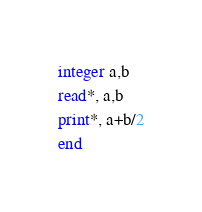Convert code to text. <code><loc_0><loc_0><loc_500><loc_500><_FORTRAN_>integer a,b
read*, a,b
print*, a+b/2
end</code> 